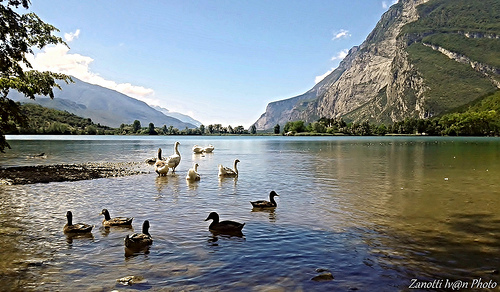<image>
Is there a duck on the water? Yes. Looking at the image, I can see the duck is positioned on top of the water, with the water providing support. Is the sea on the duck? No. The sea is not positioned on the duck. They may be near each other, but the sea is not supported by or resting on top of the duck. Where is the mountain in relation to the river? Is it in front of the river? No. The mountain is not in front of the river. The spatial positioning shows a different relationship between these objects. 